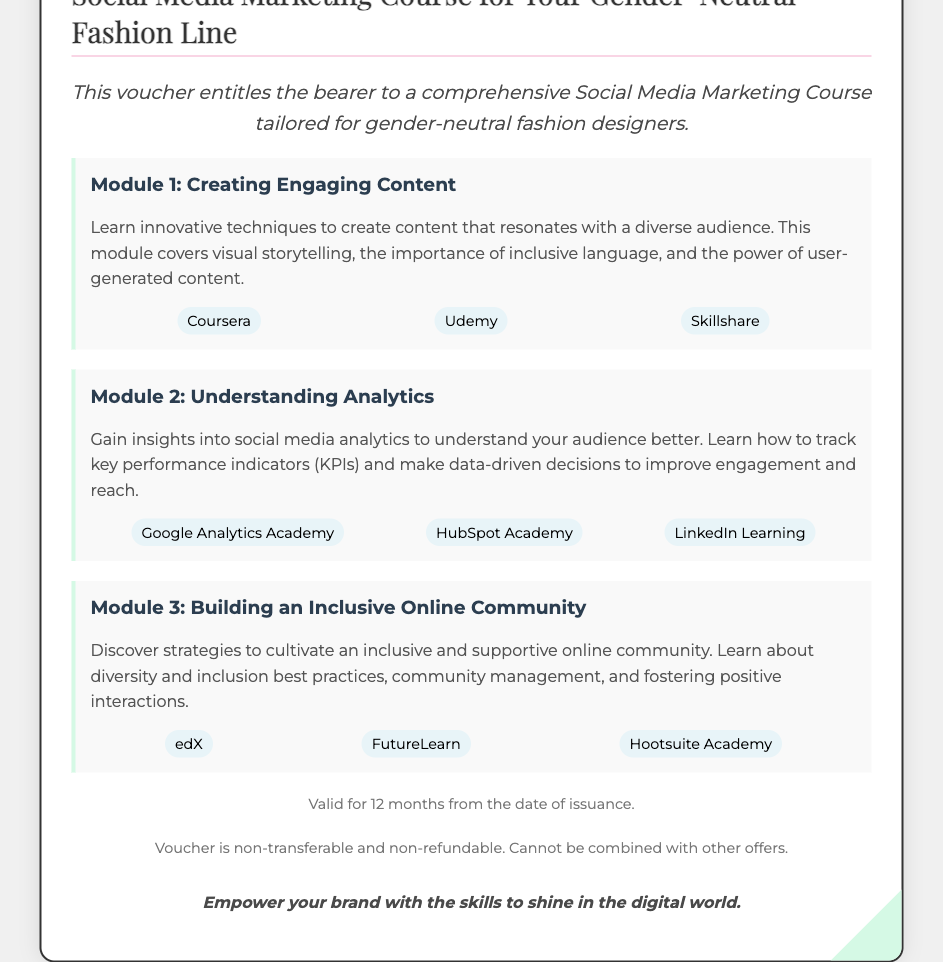What is the title of the course? The course focuses on social media marketing specifically for gender-neutral fashion lines, as described in the heading section.
Answer: Social Media Marketing Course for Your Gender-Neutral Fashion Line How many modules are included in the course? The document lists three distinct modules, each covering different topics related to social media marketing.
Answer: 3 What is the first module about? The first module introduces techniques for creating content that engages a diverse audience, which is specified in the module description.
Answer: Creating Engaging Content Which platform provides the module on understanding analytics? The document lists platforms that offer the module on understanding analytics, specifically mentioning three.
Answer: HubSpot Academy What is the validity period of the voucher? The document clearly states the voucher is valid for a certain timeframe after issuance, detailing the duration explicitly.
Answer: 12 months 